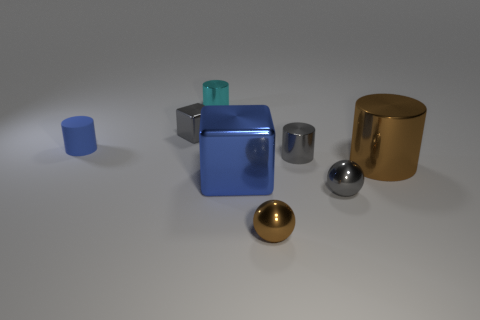What is the material of the big brown cylinder? The big brown cylinder appears to have a reflective surface and is likely made of a polished metal, perhaps bronze or copper, given its color and sheen. 